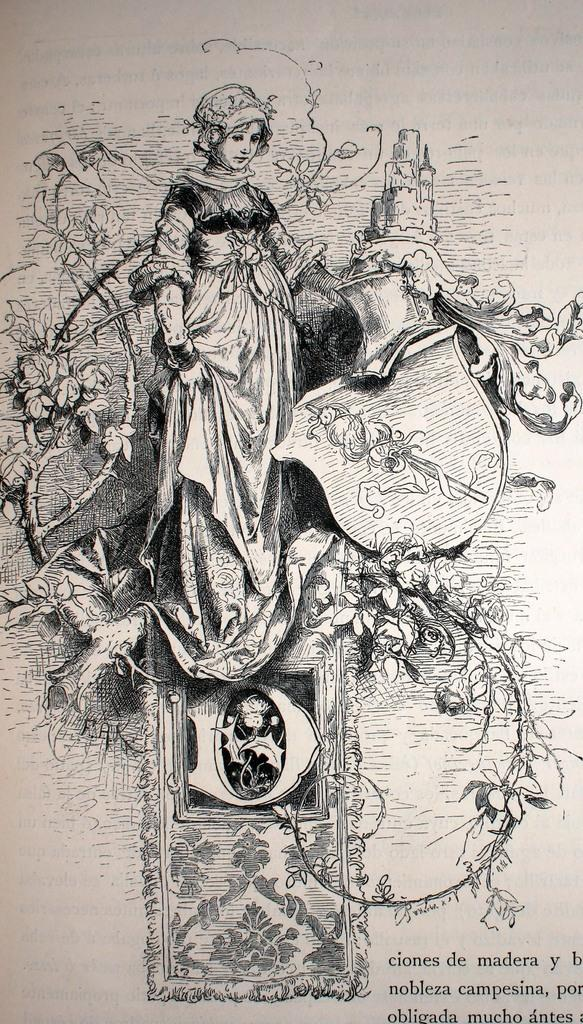What is depicted in the image? There is a sketch of a girl in the image. What is the girl doing in the sketch? The girl is standing in the sketch. Are there any words or phrases associated with the sketch? Yes, there is text associated with the sketch. What type of business is being conducted in the image? There is no indication of a business or any business-related activities in the image, as it features a sketch of a girl standing. What is the air quality like in the image? The image is a sketch, so it does not depict any real-world environment where air quality could be assessed. 